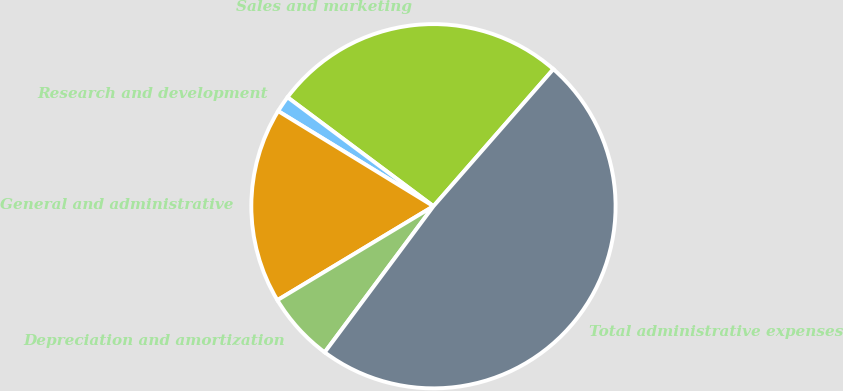<chart> <loc_0><loc_0><loc_500><loc_500><pie_chart><fcel>Sales and marketing<fcel>Research and development<fcel>General and administrative<fcel>Depreciation and amortization<fcel>Total administrative expenses<nl><fcel>26.23%<fcel>1.46%<fcel>17.37%<fcel>6.19%<fcel>48.74%<nl></chart> 